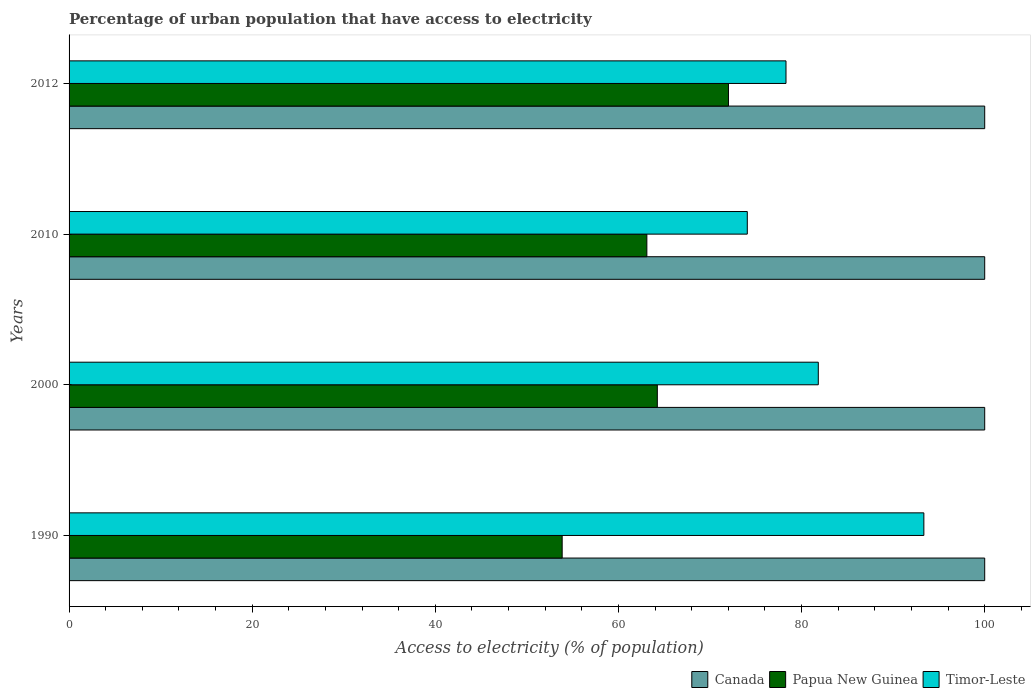How many different coloured bars are there?
Keep it short and to the point. 3. How many groups of bars are there?
Make the answer very short. 4. Are the number of bars per tick equal to the number of legend labels?
Offer a very short reply. Yes. Are the number of bars on each tick of the Y-axis equal?
Your answer should be very brief. Yes. How many bars are there on the 4th tick from the top?
Provide a succinct answer. 3. How many bars are there on the 1st tick from the bottom?
Ensure brevity in your answer.  3. What is the label of the 1st group of bars from the top?
Make the answer very short. 2012. In how many cases, is the number of bars for a given year not equal to the number of legend labels?
Ensure brevity in your answer.  0. What is the percentage of urban population that have access to electricity in Papua New Guinea in 2000?
Provide a succinct answer. 64.25. Across all years, what is the maximum percentage of urban population that have access to electricity in Timor-Leste?
Give a very brief answer. 93.35. Across all years, what is the minimum percentage of urban population that have access to electricity in Canada?
Ensure brevity in your answer.  100. In which year was the percentage of urban population that have access to electricity in Canada maximum?
Your answer should be compact. 1990. In which year was the percentage of urban population that have access to electricity in Canada minimum?
Ensure brevity in your answer.  1990. What is the total percentage of urban population that have access to electricity in Canada in the graph?
Provide a succinct answer. 400. What is the difference between the percentage of urban population that have access to electricity in Papua New Guinea in 1990 and that in 2000?
Offer a very short reply. -10.39. What is the difference between the percentage of urban population that have access to electricity in Timor-Leste in 2010 and the percentage of urban population that have access to electricity in Papua New Guinea in 2012?
Your response must be concise. 2.06. What is the average percentage of urban population that have access to electricity in Timor-Leste per year?
Provide a short and direct response. 81.89. In the year 2000, what is the difference between the percentage of urban population that have access to electricity in Papua New Guinea and percentage of urban population that have access to electricity in Timor-Leste?
Your answer should be compact. -17.58. In how many years, is the percentage of urban population that have access to electricity in Canada greater than 96 %?
Your response must be concise. 4. What is the ratio of the percentage of urban population that have access to electricity in Timor-Leste in 1990 to that in 2010?
Provide a short and direct response. 1.26. Is the percentage of urban population that have access to electricity in Canada in 2010 less than that in 2012?
Make the answer very short. No. Is the difference between the percentage of urban population that have access to electricity in Papua New Guinea in 2000 and 2012 greater than the difference between the percentage of urban population that have access to electricity in Timor-Leste in 2000 and 2012?
Your answer should be compact. No. What is the difference between the highest and the second highest percentage of urban population that have access to electricity in Papua New Guinea?
Offer a terse response. 7.77. What is the difference between the highest and the lowest percentage of urban population that have access to electricity in Papua New Guinea?
Provide a short and direct response. 18.16. Is the sum of the percentage of urban population that have access to electricity in Papua New Guinea in 2000 and 2012 greater than the maximum percentage of urban population that have access to electricity in Timor-Leste across all years?
Your answer should be very brief. Yes. What does the 1st bar from the top in 2010 represents?
Your answer should be compact. Timor-Leste. Is it the case that in every year, the sum of the percentage of urban population that have access to electricity in Papua New Guinea and percentage of urban population that have access to electricity in Timor-Leste is greater than the percentage of urban population that have access to electricity in Canada?
Ensure brevity in your answer.  Yes. Are all the bars in the graph horizontal?
Keep it short and to the point. Yes. How many years are there in the graph?
Your response must be concise. 4. What is the difference between two consecutive major ticks on the X-axis?
Offer a very short reply. 20. Does the graph contain grids?
Your answer should be very brief. No. Where does the legend appear in the graph?
Your response must be concise. Bottom right. How are the legend labels stacked?
Make the answer very short. Horizontal. What is the title of the graph?
Offer a very short reply. Percentage of urban population that have access to electricity. Does "Sudan" appear as one of the legend labels in the graph?
Your answer should be very brief. No. What is the label or title of the X-axis?
Keep it short and to the point. Access to electricity (% of population). What is the Access to electricity (% of population) of Papua New Guinea in 1990?
Keep it short and to the point. 53.85. What is the Access to electricity (% of population) in Timor-Leste in 1990?
Make the answer very short. 93.35. What is the Access to electricity (% of population) in Canada in 2000?
Provide a succinct answer. 100. What is the Access to electricity (% of population) in Papua New Guinea in 2000?
Offer a terse response. 64.25. What is the Access to electricity (% of population) of Timor-Leste in 2000?
Provide a short and direct response. 81.83. What is the Access to electricity (% of population) in Canada in 2010?
Provide a succinct answer. 100. What is the Access to electricity (% of population) in Papua New Guinea in 2010?
Provide a succinct answer. 63.1. What is the Access to electricity (% of population) of Timor-Leste in 2010?
Make the answer very short. 74.07. What is the Access to electricity (% of population) of Papua New Guinea in 2012?
Give a very brief answer. 72.01. What is the Access to electricity (% of population) of Timor-Leste in 2012?
Make the answer very short. 78.3. Across all years, what is the maximum Access to electricity (% of population) in Papua New Guinea?
Keep it short and to the point. 72.01. Across all years, what is the maximum Access to electricity (% of population) in Timor-Leste?
Offer a very short reply. 93.35. Across all years, what is the minimum Access to electricity (% of population) of Papua New Guinea?
Your answer should be compact. 53.85. Across all years, what is the minimum Access to electricity (% of population) in Timor-Leste?
Give a very brief answer. 74.07. What is the total Access to electricity (% of population) of Papua New Guinea in the graph?
Your response must be concise. 253.22. What is the total Access to electricity (% of population) in Timor-Leste in the graph?
Offer a very short reply. 327.55. What is the difference between the Access to electricity (% of population) of Canada in 1990 and that in 2000?
Make the answer very short. 0. What is the difference between the Access to electricity (% of population) of Papua New Guinea in 1990 and that in 2000?
Your answer should be very brief. -10.39. What is the difference between the Access to electricity (% of population) in Timor-Leste in 1990 and that in 2000?
Ensure brevity in your answer.  11.53. What is the difference between the Access to electricity (% of population) of Papua New Guinea in 1990 and that in 2010?
Your response must be concise. -9.25. What is the difference between the Access to electricity (% of population) in Timor-Leste in 1990 and that in 2010?
Your response must be concise. 19.28. What is the difference between the Access to electricity (% of population) of Papua New Guinea in 1990 and that in 2012?
Give a very brief answer. -18.16. What is the difference between the Access to electricity (% of population) of Timor-Leste in 1990 and that in 2012?
Give a very brief answer. 15.06. What is the difference between the Access to electricity (% of population) of Papua New Guinea in 2000 and that in 2010?
Your answer should be very brief. 1.14. What is the difference between the Access to electricity (% of population) of Timor-Leste in 2000 and that in 2010?
Give a very brief answer. 7.75. What is the difference between the Access to electricity (% of population) of Canada in 2000 and that in 2012?
Give a very brief answer. 0. What is the difference between the Access to electricity (% of population) in Papua New Guinea in 2000 and that in 2012?
Keep it short and to the point. -7.77. What is the difference between the Access to electricity (% of population) of Timor-Leste in 2000 and that in 2012?
Make the answer very short. 3.53. What is the difference between the Access to electricity (% of population) of Papua New Guinea in 2010 and that in 2012?
Offer a very short reply. -8.91. What is the difference between the Access to electricity (% of population) of Timor-Leste in 2010 and that in 2012?
Your response must be concise. -4.23. What is the difference between the Access to electricity (% of population) in Canada in 1990 and the Access to electricity (% of population) in Papua New Guinea in 2000?
Make the answer very short. 35.76. What is the difference between the Access to electricity (% of population) of Canada in 1990 and the Access to electricity (% of population) of Timor-Leste in 2000?
Give a very brief answer. 18.17. What is the difference between the Access to electricity (% of population) of Papua New Guinea in 1990 and the Access to electricity (% of population) of Timor-Leste in 2000?
Give a very brief answer. -27.97. What is the difference between the Access to electricity (% of population) in Canada in 1990 and the Access to electricity (% of population) in Papua New Guinea in 2010?
Your response must be concise. 36.9. What is the difference between the Access to electricity (% of population) of Canada in 1990 and the Access to electricity (% of population) of Timor-Leste in 2010?
Provide a short and direct response. 25.93. What is the difference between the Access to electricity (% of population) of Papua New Guinea in 1990 and the Access to electricity (% of population) of Timor-Leste in 2010?
Your answer should be compact. -20.22. What is the difference between the Access to electricity (% of population) of Canada in 1990 and the Access to electricity (% of population) of Papua New Guinea in 2012?
Provide a succinct answer. 27.99. What is the difference between the Access to electricity (% of population) in Canada in 1990 and the Access to electricity (% of population) in Timor-Leste in 2012?
Provide a succinct answer. 21.7. What is the difference between the Access to electricity (% of population) in Papua New Guinea in 1990 and the Access to electricity (% of population) in Timor-Leste in 2012?
Provide a succinct answer. -24.44. What is the difference between the Access to electricity (% of population) in Canada in 2000 and the Access to electricity (% of population) in Papua New Guinea in 2010?
Your answer should be very brief. 36.9. What is the difference between the Access to electricity (% of population) of Canada in 2000 and the Access to electricity (% of population) of Timor-Leste in 2010?
Offer a terse response. 25.93. What is the difference between the Access to electricity (% of population) of Papua New Guinea in 2000 and the Access to electricity (% of population) of Timor-Leste in 2010?
Provide a succinct answer. -9.83. What is the difference between the Access to electricity (% of population) of Canada in 2000 and the Access to electricity (% of population) of Papua New Guinea in 2012?
Provide a short and direct response. 27.99. What is the difference between the Access to electricity (% of population) in Canada in 2000 and the Access to electricity (% of population) in Timor-Leste in 2012?
Give a very brief answer. 21.7. What is the difference between the Access to electricity (% of population) of Papua New Guinea in 2000 and the Access to electricity (% of population) of Timor-Leste in 2012?
Your answer should be compact. -14.05. What is the difference between the Access to electricity (% of population) in Canada in 2010 and the Access to electricity (% of population) in Papua New Guinea in 2012?
Offer a terse response. 27.99. What is the difference between the Access to electricity (% of population) in Canada in 2010 and the Access to electricity (% of population) in Timor-Leste in 2012?
Make the answer very short. 21.7. What is the difference between the Access to electricity (% of population) in Papua New Guinea in 2010 and the Access to electricity (% of population) in Timor-Leste in 2012?
Your answer should be compact. -15.2. What is the average Access to electricity (% of population) of Canada per year?
Make the answer very short. 100. What is the average Access to electricity (% of population) of Papua New Guinea per year?
Provide a short and direct response. 63.3. What is the average Access to electricity (% of population) in Timor-Leste per year?
Your answer should be very brief. 81.89. In the year 1990, what is the difference between the Access to electricity (% of population) of Canada and Access to electricity (% of population) of Papua New Guinea?
Give a very brief answer. 46.15. In the year 1990, what is the difference between the Access to electricity (% of population) of Canada and Access to electricity (% of population) of Timor-Leste?
Provide a short and direct response. 6.65. In the year 1990, what is the difference between the Access to electricity (% of population) of Papua New Guinea and Access to electricity (% of population) of Timor-Leste?
Offer a terse response. -39.5. In the year 2000, what is the difference between the Access to electricity (% of population) in Canada and Access to electricity (% of population) in Papua New Guinea?
Offer a very short reply. 35.76. In the year 2000, what is the difference between the Access to electricity (% of population) of Canada and Access to electricity (% of population) of Timor-Leste?
Provide a short and direct response. 18.17. In the year 2000, what is the difference between the Access to electricity (% of population) of Papua New Guinea and Access to electricity (% of population) of Timor-Leste?
Give a very brief answer. -17.58. In the year 2010, what is the difference between the Access to electricity (% of population) in Canada and Access to electricity (% of population) in Papua New Guinea?
Make the answer very short. 36.9. In the year 2010, what is the difference between the Access to electricity (% of population) of Canada and Access to electricity (% of population) of Timor-Leste?
Your answer should be compact. 25.93. In the year 2010, what is the difference between the Access to electricity (% of population) of Papua New Guinea and Access to electricity (% of population) of Timor-Leste?
Your response must be concise. -10.97. In the year 2012, what is the difference between the Access to electricity (% of population) in Canada and Access to electricity (% of population) in Papua New Guinea?
Your answer should be compact. 27.99. In the year 2012, what is the difference between the Access to electricity (% of population) of Canada and Access to electricity (% of population) of Timor-Leste?
Offer a very short reply. 21.7. In the year 2012, what is the difference between the Access to electricity (% of population) of Papua New Guinea and Access to electricity (% of population) of Timor-Leste?
Your answer should be very brief. -6.28. What is the ratio of the Access to electricity (% of population) of Canada in 1990 to that in 2000?
Your answer should be compact. 1. What is the ratio of the Access to electricity (% of population) of Papua New Guinea in 1990 to that in 2000?
Keep it short and to the point. 0.84. What is the ratio of the Access to electricity (% of population) of Timor-Leste in 1990 to that in 2000?
Provide a short and direct response. 1.14. What is the ratio of the Access to electricity (% of population) in Canada in 1990 to that in 2010?
Keep it short and to the point. 1. What is the ratio of the Access to electricity (% of population) in Papua New Guinea in 1990 to that in 2010?
Provide a succinct answer. 0.85. What is the ratio of the Access to electricity (% of population) in Timor-Leste in 1990 to that in 2010?
Offer a very short reply. 1.26. What is the ratio of the Access to electricity (% of population) in Canada in 1990 to that in 2012?
Provide a succinct answer. 1. What is the ratio of the Access to electricity (% of population) in Papua New Guinea in 1990 to that in 2012?
Your answer should be compact. 0.75. What is the ratio of the Access to electricity (% of population) in Timor-Leste in 1990 to that in 2012?
Ensure brevity in your answer.  1.19. What is the ratio of the Access to electricity (% of population) in Papua New Guinea in 2000 to that in 2010?
Your answer should be very brief. 1.02. What is the ratio of the Access to electricity (% of population) of Timor-Leste in 2000 to that in 2010?
Offer a terse response. 1.1. What is the ratio of the Access to electricity (% of population) of Canada in 2000 to that in 2012?
Offer a very short reply. 1. What is the ratio of the Access to electricity (% of population) in Papua New Guinea in 2000 to that in 2012?
Provide a short and direct response. 0.89. What is the ratio of the Access to electricity (% of population) in Timor-Leste in 2000 to that in 2012?
Offer a terse response. 1.04. What is the ratio of the Access to electricity (% of population) of Canada in 2010 to that in 2012?
Keep it short and to the point. 1. What is the ratio of the Access to electricity (% of population) in Papua New Guinea in 2010 to that in 2012?
Your answer should be very brief. 0.88. What is the ratio of the Access to electricity (% of population) of Timor-Leste in 2010 to that in 2012?
Provide a short and direct response. 0.95. What is the difference between the highest and the second highest Access to electricity (% of population) of Canada?
Provide a succinct answer. 0. What is the difference between the highest and the second highest Access to electricity (% of population) in Papua New Guinea?
Your answer should be very brief. 7.77. What is the difference between the highest and the second highest Access to electricity (% of population) of Timor-Leste?
Your response must be concise. 11.53. What is the difference between the highest and the lowest Access to electricity (% of population) of Canada?
Offer a terse response. 0. What is the difference between the highest and the lowest Access to electricity (% of population) in Papua New Guinea?
Ensure brevity in your answer.  18.16. What is the difference between the highest and the lowest Access to electricity (% of population) in Timor-Leste?
Your answer should be compact. 19.28. 